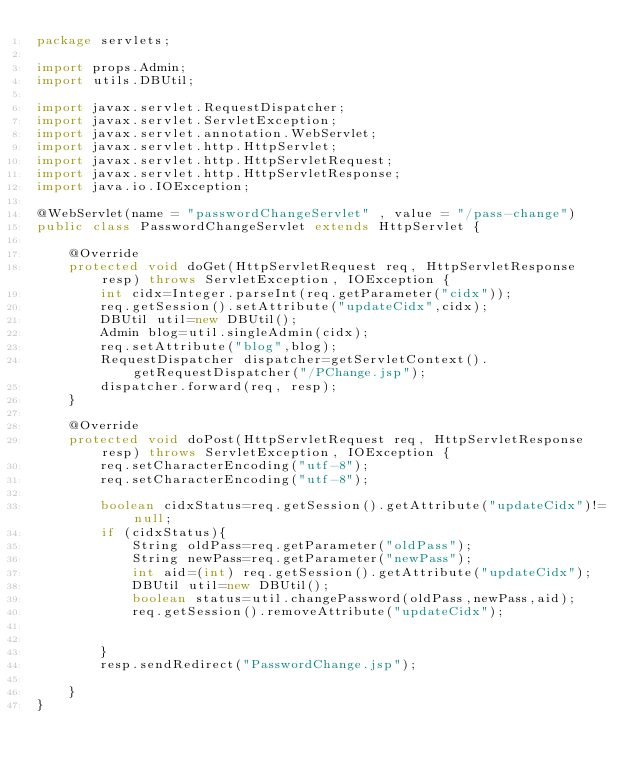<code> <loc_0><loc_0><loc_500><loc_500><_Java_>package servlets;

import props.Admin;
import utils.DBUtil;

import javax.servlet.RequestDispatcher;
import javax.servlet.ServletException;
import javax.servlet.annotation.WebServlet;
import javax.servlet.http.HttpServlet;
import javax.servlet.http.HttpServletRequest;
import javax.servlet.http.HttpServletResponse;
import java.io.IOException;

@WebServlet(name = "passwordChangeServlet" , value = "/pass-change")
public class PasswordChangeServlet extends HttpServlet {

    @Override
    protected void doGet(HttpServletRequest req, HttpServletResponse resp) throws ServletException, IOException {
        int cidx=Integer.parseInt(req.getParameter("cidx"));
        req.getSession().setAttribute("updateCidx",cidx);
        DBUtil util=new DBUtil();
        Admin blog=util.singleAdmin(cidx);
        req.setAttribute("blog",blog);
        RequestDispatcher dispatcher=getServletContext().getRequestDispatcher("/PChange.jsp");
        dispatcher.forward(req, resp);
    }

    @Override
    protected void doPost(HttpServletRequest req, HttpServletResponse resp) throws ServletException, IOException {
        req.setCharacterEncoding("utf-8");
        req.setCharacterEncoding("utf-8");

        boolean cidxStatus=req.getSession().getAttribute("updateCidx")!=null;
        if (cidxStatus){
            String oldPass=req.getParameter("oldPass");
            String newPass=req.getParameter("newPass");
            int aid=(int) req.getSession().getAttribute("updateCidx");
            DBUtil util=new DBUtil();
            boolean status=util.changePassword(oldPass,newPass,aid);
            req.getSession().removeAttribute("updateCidx");


        }
        resp.sendRedirect("PasswordChange.jsp");

    }
}

</code> 